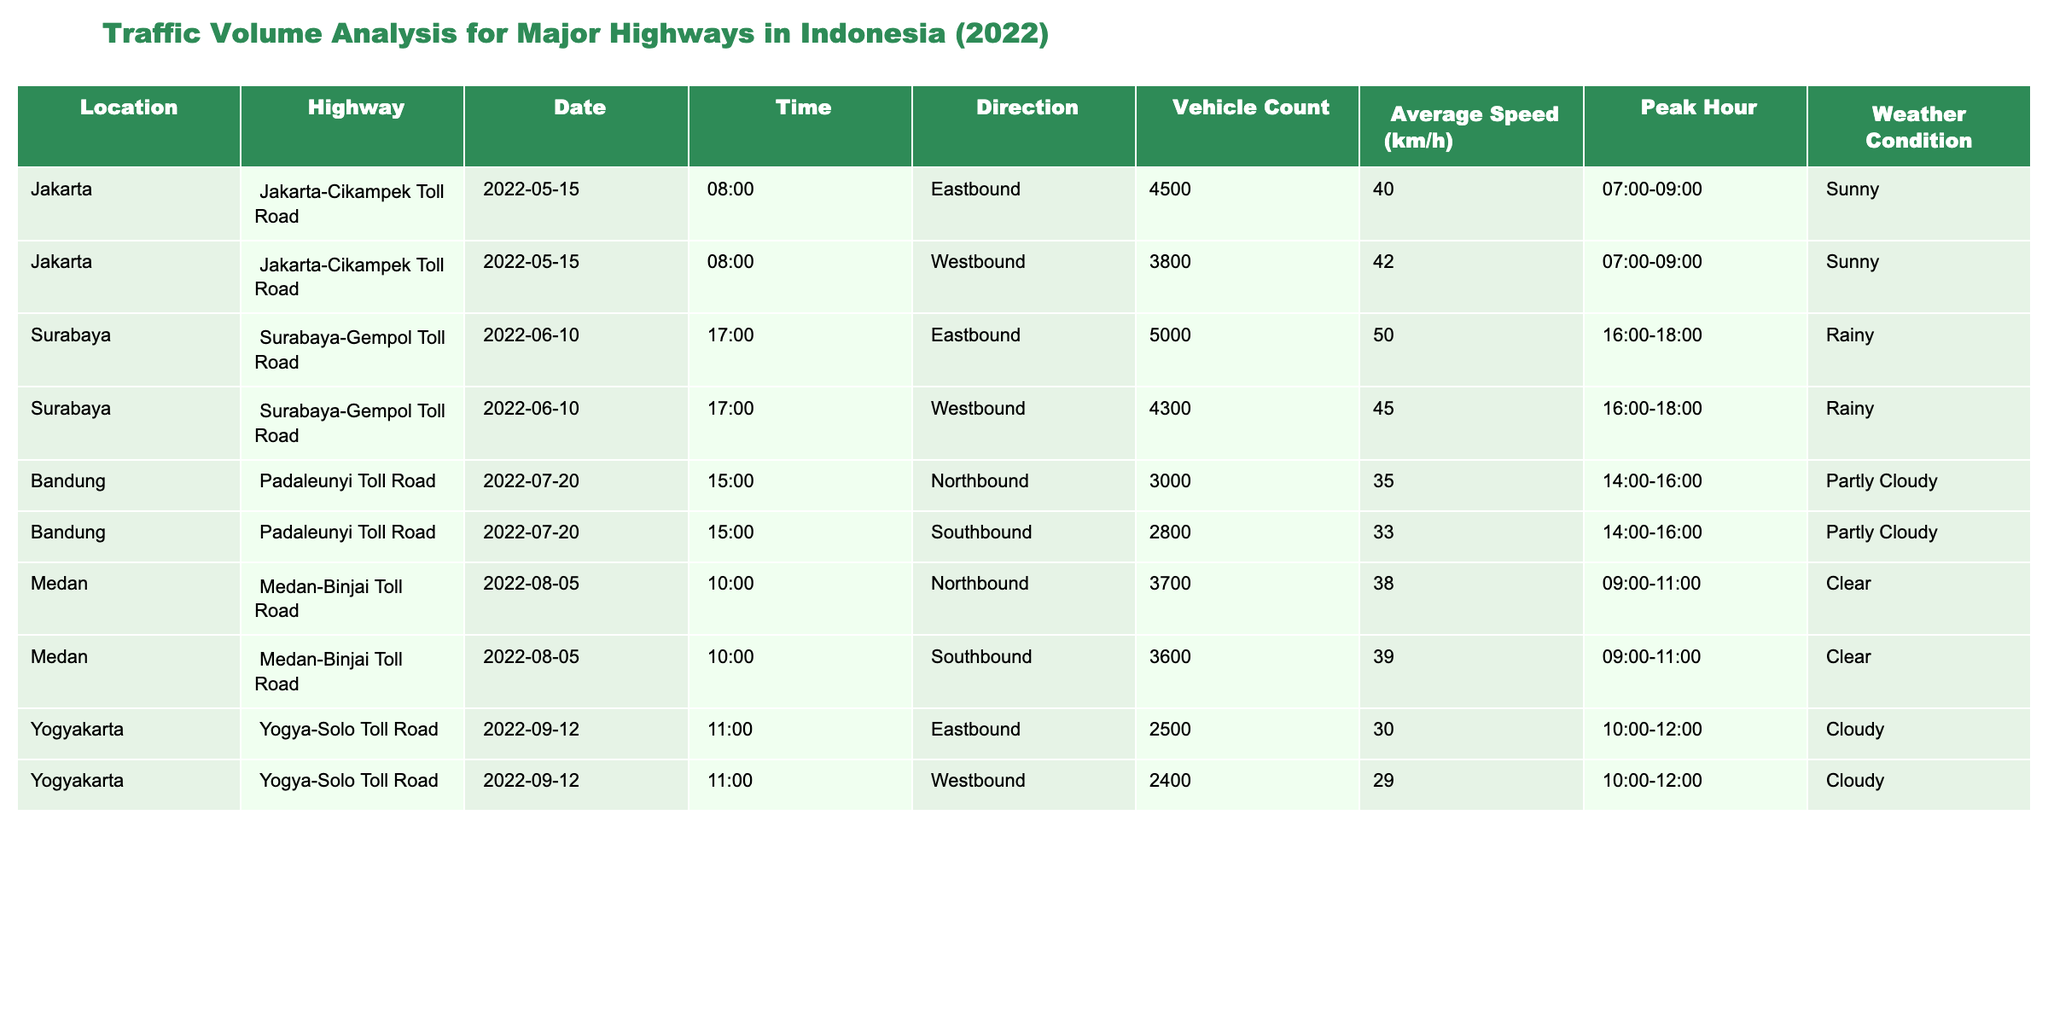What is the total vehicle count for the Jakarta-Cikampek Toll Road on May 15, 2022? The table lists two directions (Eastbound and Westbound) for the Jakarta-Cikampek Toll Road on that date. The vehicle count for Eastbound is 4500 and for Westbound is 3800. Summing these counts gives 4500 + 3800 = 8300.
Answer: 8300 Which highway recorded the highest average speed and what was that speed? From the table, we need to compare the average speeds of all the highways. The average speeds listed are 40, 42, 50, 45, 35, 33, 38, 39, 30, and 29 km/h. The highest average speed is 50 km/h for the Surabaya-Gempol Toll Road.
Answer: 50 Did the vehicle counts decrease in the Southbound direction compared to the Northbound direction for the Padaleunyi Toll Road? Looking at the data for the Padaleunyi Toll Road, the Northbound vehicle count is 3000 and the Southbound vehicle count is 2800. Since 2800 is less than 3000, this indicates a decrease in vehicle count for the Southbound direction.
Answer: Yes What are the peak hours for traffic on the Surabaya-Gempol Toll Road? The table states that the peak hours for the Surabaya-Gempol Toll Road on June 10, 2022, are listed as 16:00-18:00 for both Eastbound and Westbound directions.
Answer: 16:00-18:00 What is the overall average vehicle count across all reported highways? To find the overall average vehicle count, we add up all vehicle counts: 4500 + 3800 + 5000 + 4300 + 3000 + 2800 + 3700 + 3600 + 2500 + 2400 =  45000. Then, we divide this sum by the number of entries (10): 45000/10 = 4500.
Answer: 4500 What was the weather condition during the peak traffic on the Medan-Binjai Toll Road? The Medan-Binjai Toll Road recorded a peak traffic condition on August 5, 2022. The weather condition during this time was noted as Clear.
Answer: Clear Which direction had higher vehicle counts on the Yogya-Solo Toll Road? The vehicle counts for the Yogya-Solo Toll Road show that Eastbound had a count of 2500 and Westbound had a count of 2400 on September 12, 2022. Since 2500 is greater than 2400, the Eastbound direction had higher vehicle counts.
Answer: Eastbound How many locations are reported in the traffic analysis? The table lists traffic data from four distinct locations: Jakarta, Surabaya, Bandung, and Medan. Hence, there are a total of four locations reported in the analysis.
Answer: 4 